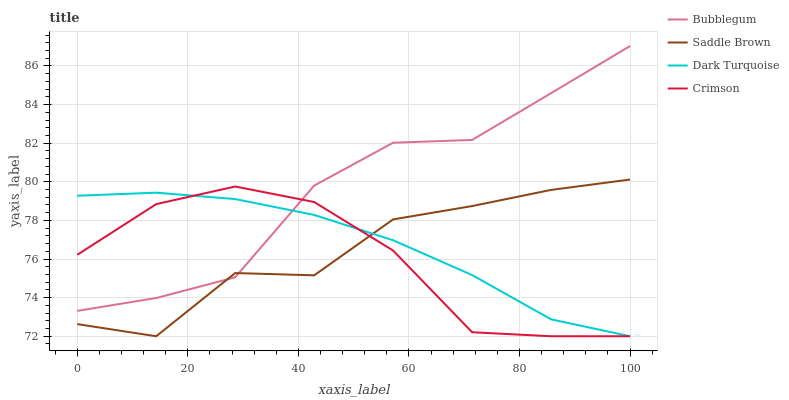Does Crimson have the minimum area under the curve?
Answer yes or no. Yes. Does Bubblegum have the maximum area under the curve?
Answer yes or no. Yes. Does Dark Turquoise have the minimum area under the curve?
Answer yes or no. No. Does Dark Turquoise have the maximum area under the curve?
Answer yes or no. No. Is Dark Turquoise the smoothest?
Answer yes or no. Yes. Is Saddle Brown the roughest?
Answer yes or no. Yes. Is Saddle Brown the smoothest?
Answer yes or no. No. Is Dark Turquoise the roughest?
Answer yes or no. No. Does Crimson have the lowest value?
Answer yes or no. Yes. Does Bubblegum have the lowest value?
Answer yes or no. No. Does Bubblegum have the highest value?
Answer yes or no. Yes. Does Saddle Brown have the highest value?
Answer yes or no. No. Does Dark Turquoise intersect Crimson?
Answer yes or no. Yes. Is Dark Turquoise less than Crimson?
Answer yes or no. No. Is Dark Turquoise greater than Crimson?
Answer yes or no. No. 